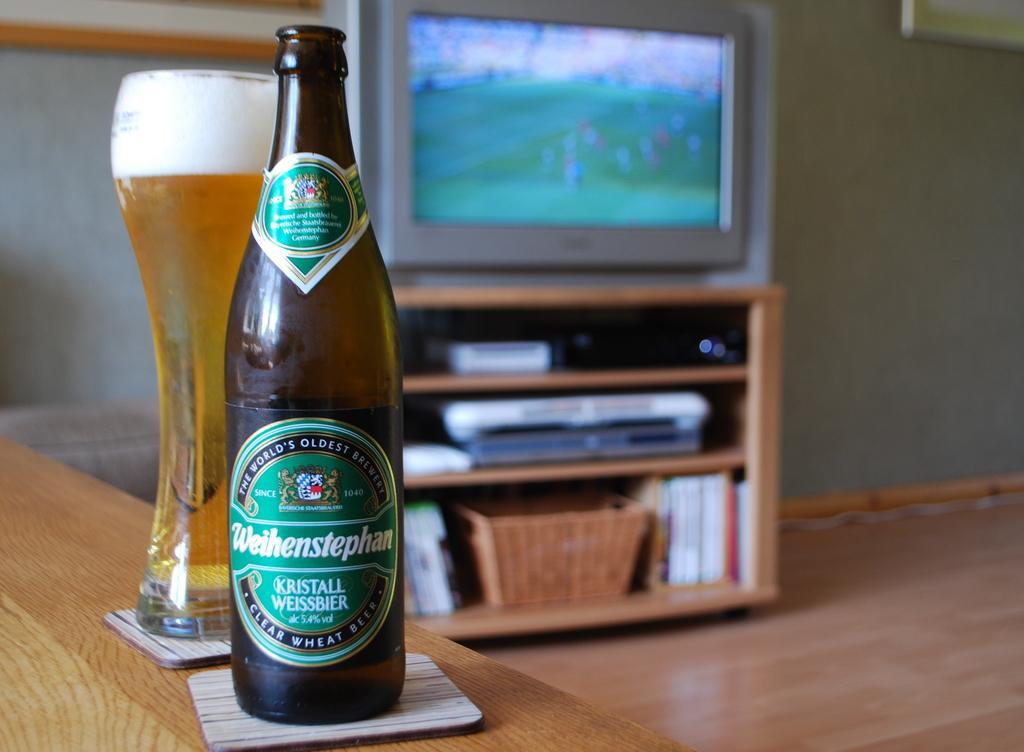<image>
Describe the image concisely. A bottle of clear wheat beer sits on a table next to a full glass. 